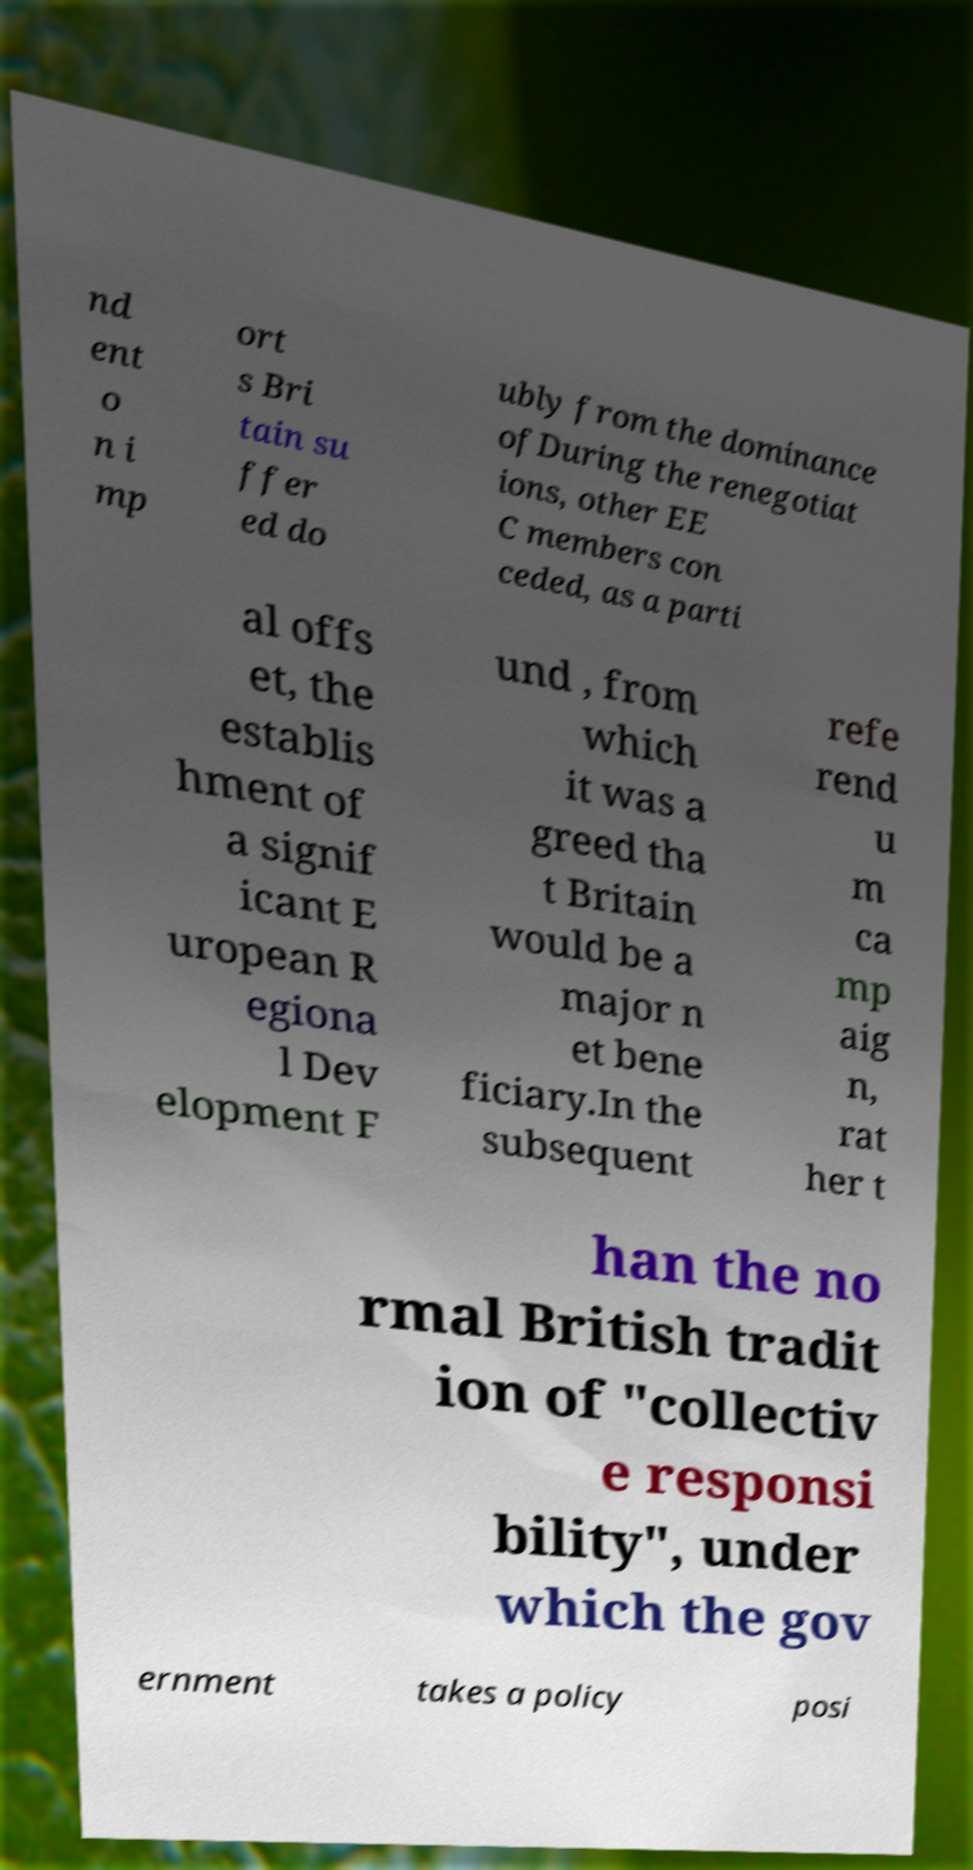There's text embedded in this image that I need extracted. Can you transcribe it verbatim? nd ent o n i mp ort s Bri tain su ffer ed do ubly from the dominance ofDuring the renegotiat ions, other EE C members con ceded, as a parti al offs et, the establis hment of a signif icant E uropean R egiona l Dev elopment F und , from which it was a greed tha t Britain would be a major n et bene ficiary.In the subsequent refe rend u m ca mp aig n, rat her t han the no rmal British tradit ion of "collectiv e responsi bility", under which the gov ernment takes a policy posi 